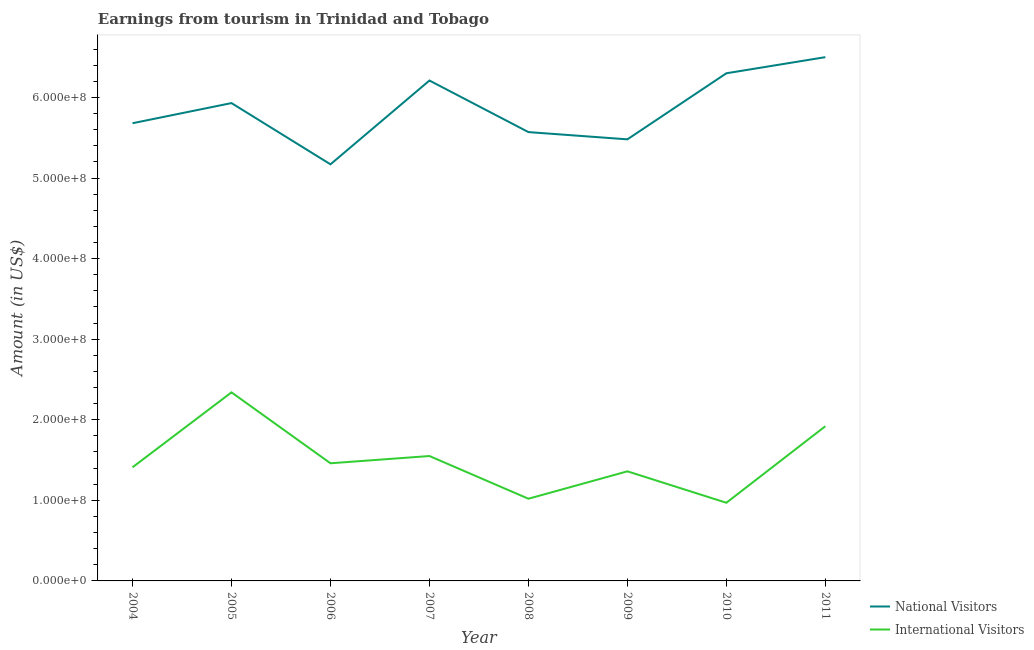What is the amount earned from national visitors in 2006?
Keep it short and to the point. 5.17e+08. Across all years, what is the maximum amount earned from national visitors?
Your answer should be very brief. 6.50e+08. Across all years, what is the minimum amount earned from national visitors?
Ensure brevity in your answer.  5.17e+08. In which year was the amount earned from national visitors minimum?
Give a very brief answer. 2006. What is the total amount earned from international visitors in the graph?
Provide a succinct answer. 1.20e+09. What is the difference between the amount earned from national visitors in 2005 and that in 2008?
Your answer should be compact. 3.60e+07. What is the difference between the amount earned from national visitors in 2007 and the amount earned from international visitors in 2009?
Provide a short and direct response. 4.85e+08. What is the average amount earned from national visitors per year?
Your answer should be very brief. 5.86e+08. In the year 2005, what is the difference between the amount earned from national visitors and amount earned from international visitors?
Ensure brevity in your answer.  3.59e+08. In how many years, is the amount earned from national visitors greater than 80000000 US$?
Your answer should be very brief. 8. What is the ratio of the amount earned from international visitors in 2004 to that in 2006?
Ensure brevity in your answer.  0.97. Is the amount earned from international visitors in 2005 less than that in 2008?
Give a very brief answer. No. What is the difference between the highest and the lowest amount earned from international visitors?
Your answer should be compact. 1.37e+08. In how many years, is the amount earned from national visitors greater than the average amount earned from national visitors taken over all years?
Your response must be concise. 4. Does the amount earned from international visitors monotonically increase over the years?
Ensure brevity in your answer.  No. Is the amount earned from international visitors strictly greater than the amount earned from national visitors over the years?
Provide a short and direct response. No. Is the amount earned from international visitors strictly less than the amount earned from national visitors over the years?
Give a very brief answer. Yes. How many years are there in the graph?
Ensure brevity in your answer.  8. Does the graph contain any zero values?
Give a very brief answer. No. Does the graph contain grids?
Provide a succinct answer. No. Where does the legend appear in the graph?
Ensure brevity in your answer.  Bottom right. How many legend labels are there?
Your response must be concise. 2. What is the title of the graph?
Provide a short and direct response. Earnings from tourism in Trinidad and Tobago. Does "Study and work" appear as one of the legend labels in the graph?
Your answer should be very brief. No. What is the Amount (in US$) in National Visitors in 2004?
Provide a short and direct response. 5.68e+08. What is the Amount (in US$) of International Visitors in 2004?
Make the answer very short. 1.41e+08. What is the Amount (in US$) of National Visitors in 2005?
Give a very brief answer. 5.93e+08. What is the Amount (in US$) of International Visitors in 2005?
Provide a short and direct response. 2.34e+08. What is the Amount (in US$) in National Visitors in 2006?
Offer a very short reply. 5.17e+08. What is the Amount (in US$) in International Visitors in 2006?
Keep it short and to the point. 1.46e+08. What is the Amount (in US$) in National Visitors in 2007?
Ensure brevity in your answer.  6.21e+08. What is the Amount (in US$) in International Visitors in 2007?
Your answer should be very brief. 1.55e+08. What is the Amount (in US$) of National Visitors in 2008?
Ensure brevity in your answer.  5.57e+08. What is the Amount (in US$) in International Visitors in 2008?
Give a very brief answer. 1.02e+08. What is the Amount (in US$) in National Visitors in 2009?
Your answer should be very brief. 5.48e+08. What is the Amount (in US$) of International Visitors in 2009?
Provide a short and direct response. 1.36e+08. What is the Amount (in US$) in National Visitors in 2010?
Offer a very short reply. 6.30e+08. What is the Amount (in US$) of International Visitors in 2010?
Offer a terse response. 9.70e+07. What is the Amount (in US$) of National Visitors in 2011?
Provide a short and direct response. 6.50e+08. What is the Amount (in US$) in International Visitors in 2011?
Offer a terse response. 1.92e+08. Across all years, what is the maximum Amount (in US$) in National Visitors?
Offer a terse response. 6.50e+08. Across all years, what is the maximum Amount (in US$) of International Visitors?
Provide a succinct answer. 2.34e+08. Across all years, what is the minimum Amount (in US$) of National Visitors?
Keep it short and to the point. 5.17e+08. Across all years, what is the minimum Amount (in US$) of International Visitors?
Give a very brief answer. 9.70e+07. What is the total Amount (in US$) in National Visitors in the graph?
Make the answer very short. 4.68e+09. What is the total Amount (in US$) in International Visitors in the graph?
Provide a succinct answer. 1.20e+09. What is the difference between the Amount (in US$) of National Visitors in 2004 and that in 2005?
Give a very brief answer. -2.50e+07. What is the difference between the Amount (in US$) of International Visitors in 2004 and that in 2005?
Your response must be concise. -9.30e+07. What is the difference between the Amount (in US$) in National Visitors in 2004 and that in 2006?
Offer a terse response. 5.10e+07. What is the difference between the Amount (in US$) in International Visitors in 2004 and that in 2006?
Offer a very short reply. -5.00e+06. What is the difference between the Amount (in US$) in National Visitors in 2004 and that in 2007?
Keep it short and to the point. -5.30e+07. What is the difference between the Amount (in US$) in International Visitors in 2004 and that in 2007?
Offer a terse response. -1.40e+07. What is the difference between the Amount (in US$) in National Visitors in 2004 and that in 2008?
Offer a terse response. 1.10e+07. What is the difference between the Amount (in US$) of International Visitors in 2004 and that in 2008?
Offer a terse response. 3.90e+07. What is the difference between the Amount (in US$) of International Visitors in 2004 and that in 2009?
Offer a terse response. 5.00e+06. What is the difference between the Amount (in US$) in National Visitors in 2004 and that in 2010?
Keep it short and to the point. -6.20e+07. What is the difference between the Amount (in US$) of International Visitors in 2004 and that in 2010?
Your answer should be very brief. 4.40e+07. What is the difference between the Amount (in US$) of National Visitors in 2004 and that in 2011?
Offer a terse response. -8.20e+07. What is the difference between the Amount (in US$) of International Visitors in 2004 and that in 2011?
Your answer should be very brief. -5.10e+07. What is the difference between the Amount (in US$) in National Visitors in 2005 and that in 2006?
Provide a succinct answer. 7.60e+07. What is the difference between the Amount (in US$) in International Visitors in 2005 and that in 2006?
Make the answer very short. 8.80e+07. What is the difference between the Amount (in US$) in National Visitors in 2005 and that in 2007?
Make the answer very short. -2.80e+07. What is the difference between the Amount (in US$) in International Visitors in 2005 and that in 2007?
Give a very brief answer. 7.90e+07. What is the difference between the Amount (in US$) in National Visitors in 2005 and that in 2008?
Keep it short and to the point. 3.60e+07. What is the difference between the Amount (in US$) in International Visitors in 2005 and that in 2008?
Your answer should be compact. 1.32e+08. What is the difference between the Amount (in US$) of National Visitors in 2005 and that in 2009?
Offer a terse response. 4.50e+07. What is the difference between the Amount (in US$) of International Visitors in 2005 and that in 2009?
Make the answer very short. 9.80e+07. What is the difference between the Amount (in US$) of National Visitors in 2005 and that in 2010?
Give a very brief answer. -3.70e+07. What is the difference between the Amount (in US$) of International Visitors in 2005 and that in 2010?
Offer a terse response. 1.37e+08. What is the difference between the Amount (in US$) in National Visitors in 2005 and that in 2011?
Your answer should be compact. -5.70e+07. What is the difference between the Amount (in US$) of International Visitors in 2005 and that in 2011?
Keep it short and to the point. 4.20e+07. What is the difference between the Amount (in US$) in National Visitors in 2006 and that in 2007?
Your answer should be very brief. -1.04e+08. What is the difference between the Amount (in US$) of International Visitors in 2006 and that in 2007?
Provide a succinct answer. -9.00e+06. What is the difference between the Amount (in US$) of National Visitors in 2006 and that in 2008?
Provide a succinct answer. -4.00e+07. What is the difference between the Amount (in US$) of International Visitors in 2006 and that in 2008?
Give a very brief answer. 4.40e+07. What is the difference between the Amount (in US$) of National Visitors in 2006 and that in 2009?
Offer a very short reply. -3.10e+07. What is the difference between the Amount (in US$) of International Visitors in 2006 and that in 2009?
Provide a succinct answer. 1.00e+07. What is the difference between the Amount (in US$) in National Visitors in 2006 and that in 2010?
Ensure brevity in your answer.  -1.13e+08. What is the difference between the Amount (in US$) of International Visitors in 2006 and that in 2010?
Provide a succinct answer. 4.90e+07. What is the difference between the Amount (in US$) of National Visitors in 2006 and that in 2011?
Provide a succinct answer. -1.33e+08. What is the difference between the Amount (in US$) of International Visitors in 2006 and that in 2011?
Your answer should be very brief. -4.60e+07. What is the difference between the Amount (in US$) in National Visitors in 2007 and that in 2008?
Offer a terse response. 6.40e+07. What is the difference between the Amount (in US$) of International Visitors in 2007 and that in 2008?
Make the answer very short. 5.30e+07. What is the difference between the Amount (in US$) of National Visitors in 2007 and that in 2009?
Offer a very short reply. 7.30e+07. What is the difference between the Amount (in US$) in International Visitors in 2007 and that in 2009?
Your response must be concise. 1.90e+07. What is the difference between the Amount (in US$) in National Visitors in 2007 and that in 2010?
Make the answer very short. -9.00e+06. What is the difference between the Amount (in US$) in International Visitors in 2007 and that in 2010?
Give a very brief answer. 5.80e+07. What is the difference between the Amount (in US$) in National Visitors in 2007 and that in 2011?
Ensure brevity in your answer.  -2.90e+07. What is the difference between the Amount (in US$) in International Visitors in 2007 and that in 2011?
Your answer should be compact. -3.70e+07. What is the difference between the Amount (in US$) in National Visitors in 2008 and that in 2009?
Give a very brief answer. 9.00e+06. What is the difference between the Amount (in US$) in International Visitors in 2008 and that in 2009?
Your answer should be compact. -3.40e+07. What is the difference between the Amount (in US$) of National Visitors in 2008 and that in 2010?
Provide a succinct answer. -7.30e+07. What is the difference between the Amount (in US$) in International Visitors in 2008 and that in 2010?
Give a very brief answer. 5.00e+06. What is the difference between the Amount (in US$) of National Visitors in 2008 and that in 2011?
Provide a succinct answer. -9.30e+07. What is the difference between the Amount (in US$) in International Visitors in 2008 and that in 2011?
Ensure brevity in your answer.  -9.00e+07. What is the difference between the Amount (in US$) in National Visitors in 2009 and that in 2010?
Provide a short and direct response. -8.20e+07. What is the difference between the Amount (in US$) of International Visitors in 2009 and that in 2010?
Your answer should be very brief. 3.90e+07. What is the difference between the Amount (in US$) in National Visitors in 2009 and that in 2011?
Give a very brief answer. -1.02e+08. What is the difference between the Amount (in US$) in International Visitors in 2009 and that in 2011?
Your answer should be very brief. -5.60e+07. What is the difference between the Amount (in US$) in National Visitors in 2010 and that in 2011?
Your answer should be compact. -2.00e+07. What is the difference between the Amount (in US$) in International Visitors in 2010 and that in 2011?
Your answer should be compact. -9.50e+07. What is the difference between the Amount (in US$) of National Visitors in 2004 and the Amount (in US$) of International Visitors in 2005?
Keep it short and to the point. 3.34e+08. What is the difference between the Amount (in US$) in National Visitors in 2004 and the Amount (in US$) in International Visitors in 2006?
Provide a short and direct response. 4.22e+08. What is the difference between the Amount (in US$) of National Visitors in 2004 and the Amount (in US$) of International Visitors in 2007?
Provide a short and direct response. 4.13e+08. What is the difference between the Amount (in US$) of National Visitors in 2004 and the Amount (in US$) of International Visitors in 2008?
Provide a short and direct response. 4.66e+08. What is the difference between the Amount (in US$) of National Visitors in 2004 and the Amount (in US$) of International Visitors in 2009?
Provide a short and direct response. 4.32e+08. What is the difference between the Amount (in US$) of National Visitors in 2004 and the Amount (in US$) of International Visitors in 2010?
Offer a very short reply. 4.71e+08. What is the difference between the Amount (in US$) in National Visitors in 2004 and the Amount (in US$) in International Visitors in 2011?
Keep it short and to the point. 3.76e+08. What is the difference between the Amount (in US$) of National Visitors in 2005 and the Amount (in US$) of International Visitors in 2006?
Make the answer very short. 4.47e+08. What is the difference between the Amount (in US$) of National Visitors in 2005 and the Amount (in US$) of International Visitors in 2007?
Your answer should be very brief. 4.38e+08. What is the difference between the Amount (in US$) in National Visitors in 2005 and the Amount (in US$) in International Visitors in 2008?
Offer a very short reply. 4.91e+08. What is the difference between the Amount (in US$) in National Visitors in 2005 and the Amount (in US$) in International Visitors in 2009?
Provide a succinct answer. 4.57e+08. What is the difference between the Amount (in US$) of National Visitors in 2005 and the Amount (in US$) of International Visitors in 2010?
Your answer should be very brief. 4.96e+08. What is the difference between the Amount (in US$) in National Visitors in 2005 and the Amount (in US$) in International Visitors in 2011?
Provide a short and direct response. 4.01e+08. What is the difference between the Amount (in US$) of National Visitors in 2006 and the Amount (in US$) of International Visitors in 2007?
Keep it short and to the point. 3.62e+08. What is the difference between the Amount (in US$) of National Visitors in 2006 and the Amount (in US$) of International Visitors in 2008?
Your answer should be very brief. 4.15e+08. What is the difference between the Amount (in US$) of National Visitors in 2006 and the Amount (in US$) of International Visitors in 2009?
Offer a terse response. 3.81e+08. What is the difference between the Amount (in US$) in National Visitors in 2006 and the Amount (in US$) in International Visitors in 2010?
Your answer should be compact. 4.20e+08. What is the difference between the Amount (in US$) of National Visitors in 2006 and the Amount (in US$) of International Visitors in 2011?
Provide a short and direct response. 3.25e+08. What is the difference between the Amount (in US$) in National Visitors in 2007 and the Amount (in US$) in International Visitors in 2008?
Provide a short and direct response. 5.19e+08. What is the difference between the Amount (in US$) of National Visitors in 2007 and the Amount (in US$) of International Visitors in 2009?
Offer a terse response. 4.85e+08. What is the difference between the Amount (in US$) of National Visitors in 2007 and the Amount (in US$) of International Visitors in 2010?
Provide a succinct answer. 5.24e+08. What is the difference between the Amount (in US$) of National Visitors in 2007 and the Amount (in US$) of International Visitors in 2011?
Offer a terse response. 4.29e+08. What is the difference between the Amount (in US$) of National Visitors in 2008 and the Amount (in US$) of International Visitors in 2009?
Offer a very short reply. 4.21e+08. What is the difference between the Amount (in US$) in National Visitors in 2008 and the Amount (in US$) in International Visitors in 2010?
Provide a short and direct response. 4.60e+08. What is the difference between the Amount (in US$) of National Visitors in 2008 and the Amount (in US$) of International Visitors in 2011?
Offer a terse response. 3.65e+08. What is the difference between the Amount (in US$) in National Visitors in 2009 and the Amount (in US$) in International Visitors in 2010?
Your response must be concise. 4.51e+08. What is the difference between the Amount (in US$) of National Visitors in 2009 and the Amount (in US$) of International Visitors in 2011?
Your response must be concise. 3.56e+08. What is the difference between the Amount (in US$) of National Visitors in 2010 and the Amount (in US$) of International Visitors in 2011?
Make the answer very short. 4.38e+08. What is the average Amount (in US$) in National Visitors per year?
Ensure brevity in your answer.  5.86e+08. What is the average Amount (in US$) of International Visitors per year?
Your response must be concise. 1.50e+08. In the year 2004, what is the difference between the Amount (in US$) in National Visitors and Amount (in US$) in International Visitors?
Offer a very short reply. 4.27e+08. In the year 2005, what is the difference between the Amount (in US$) of National Visitors and Amount (in US$) of International Visitors?
Offer a very short reply. 3.59e+08. In the year 2006, what is the difference between the Amount (in US$) of National Visitors and Amount (in US$) of International Visitors?
Provide a succinct answer. 3.71e+08. In the year 2007, what is the difference between the Amount (in US$) of National Visitors and Amount (in US$) of International Visitors?
Keep it short and to the point. 4.66e+08. In the year 2008, what is the difference between the Amount (in US$) of National Visitors and Amount (in US$) of International Visitors?
Your response must be concise. 4.55e+08. In the year 2009, what is the difference between the Amount (in US$) of National Visitors and Amount (in US$) of International Visitors?
Your answer should be very brief. 4.12e+08. In the year 2010, what is the difference between the Amount (in US$) in National Visitors and Amount (in US$) in International Visitors?
Provide a short and direct response. 5.33e+08. In the year 2011, what is the difference between the Amount (in US$) in National Visitors and Amount (in US$) in International Visitors?
Your answer should be compact. 4.58e+08. What is the ratio of the Amount (in US$) in National Visitors in 2004 to that in 2005?
Offer a very short reply. 0.96. What is the ratio of the Amount (in US$) in International Visitors in 2004 to that in 2005?
Offer a very short reply. 0.6. What is the ratio of the Amount (in US$) of National Visitors in 2004 to that in 2006?
Your answer should be very brief. 1.1. What is the ratio of the Amount (in US$) in International Visitors in 2004 to that in 2006?
Ensure brevity in your answer.  0.97. What is the ratio of the Amount (in US$) of National Visitors in 2004 to that in 2007?
Offer a terse response. 0.91. What is the ratio of the Amount (in US$) in International Visitors in 2004 to that in 2007?
Provide a short and direct response. 0.91. What is the ratio of the Amount (in US$) in National Visitors in 2004 to that in 2008?
Provide a short and direct response. 1.02. What is the ratio of the Amount (in US$) in International Visitors in 2004 to that in 2008?
Your answer should be very brief. 1.38. What is the ratio of the Amount (in US$) of National Visitors in 2004 to that in 2009?
Ensure brevity in your answer.  1.04. What is the ratio of the Amount (in US$) in International Visitors in 2004 to that in 2009?
Keep it short and to the point. 1.04. What is the ratio of the Amount (in US$) of National Visitors in 2004 to that in 2010?
Make the answer very short. 0.9. What is the ratio of the Amount (in US$) in International Visitors in 2004 to that in 2010?
Your answer should be compact. 1.45. What is the ratio of the Amount (in US$) in National Visitors in 2004 to that in 2011?
Make the answer very short. 0.87. What is the ratio of the Amount (in US$) in International Visitors in 2004 to that in 2011?
Offer a very short reply. 0.73. What is the ratio of the Amount (in US$) of National Visitors in 2005 to that in 2006?
Ensure brevity in your answer.  1.15. What is the ratio of the Amount (in US$) in International Visitors in 2005 to that in 2006?
Your answer should be very brief. 1.6. What is the ratio of the Amount (in US$) in National Visitors in 2005 to that in 2007?
Offer a terse response. 0.95. What is the ratio of the Amount (in US$) of International Visitors in 2005 to that in 2007?
Give a very brief answer. 1.51. What is the ratio of the Amount (in US$) in National Visitors in 2005 to that in 2008?
Offer a very short reply. 1.06. What is the ratio of the Amount (in US$) of International Visitors in 2005 to that in 2008?
Offer a very short reply. 2.29. What is the ratio of the Amount (in US$) of National Visitors in 2005 to that in 2009?
Keep it short and to the point. 1.08. What is the ratio of the Amount (in US$) in International Visitors in 2005 to that in 2009?
Keep it short and to the point. 1.72. What is the ratio of the Amount (in US$) of National Visitors in 2005 to that in 2010?
Offer a terse response. 0.94. What is the ratio of the Amount (in US$) in International Visitors in 2005 to that in 2010?
Your response must be concise. 2.41. What is the ratio of the Amount (in US$) of National Visitors in 2005 to that in 2011?
Offer a very short reply. 0.91. What is the ratio of the Amount (in US$) of International Visitors in 2005 to that in 2011?
Your answer should be very brief. 1.22. What is the ratio of the Amount (in US$) of National Visitors in 2006 to that in 2007?
Give a very brief answer. 0.83. What is the ratio of the Amount (in US$) in International Visitors in 2006 to that in 2007?
Provide a short and direct response. 0.94. What is the ratio of the Amount (in US$) in National Visitors in 2006 to that in 2008?
Make the answer very short. 0.93. What is the ratio of the Amount (in US$) of International Visitors in 2006 to that in 2008?
Give a very brief answer. 1.43. What is the ratio of the Amount (in US$) in National Visitors in 2006 to that in 2009?
Offer a very short reply. 0.94. What is the ratio of the Amount (in US$) of International Visitors in 2006 to that in 2009?
Provide a short and direct response. 1.07. What is the ratio of the Amount (in US$) in National Visitors in 2006 to that in 2010?
Provide a succinct answer. 0.82. What is the ratio of the Amount (in US$) in International Visitors in 2006 to that in 2010?
Your answer should be compact. 1.51. What is the ratio of the Amount (in US$) of National Visitors in 2006 to that in 2011?
Keep it short and to the point. 0.8. What is the ratio of the Amount (in US$) of International Visitors in 2006 to that in 2011?
Offer a terse response. 0.76. What is the ratio of the Amount (in US$) in National Visitors in 2007 to that in 2008?
Give a very brief answer. 1.11. What is the ratio of the Amount (in US$) in International Visitors in 2007 to that in 2008?
Give a very brief answer. 1.52. What is the ratio of the Amount (in US$) of National Visitors in 2007 to that in 2009?
Keep it short and to the point. 1.13. What is the ratio of the Amount (in US$) in International Visitors in 2007 to that in 2009?
Provide a succinct answer. 1.14. What is the ratio of the Amount (in US$) in National Visitors in 2007 to that in 2010?
Provide a succinct answer. 0.99. What is the ratio of the Amount (in US$) of International Visitors in 2007 to that in 2010?
Make the answer very short. 1.6. What is the ratio of the Amount (in US$) of National Visitors in 2007 to that in 2011?
Your response must be concise. 0.96. What is the ratio of the Amount (in US$) of International Visitors in 2007 to that in 2011?
Your answer should be compact. 0.81. What is the ratio of the Amount (in US$) of National Visitors in 2008 to that in 2009?
Offer a very short reply. 1.02. What is the ratio of the Amount (in US$) of National Visitors in 2008 to that in 2010?
Offer a terse response. 0.88. What is the ratio of the Amount (in US$) of International Visitors in 2008 to that in 2010?
Ensure brevity in your answer.  1.05. What is the ratio of the Amount (in US$) of National Visitors in 2008 to that in 2011?
Offer a very short reply. 0.86. What is the ratio of the Amount (in US$) in International Visitors in 2008 to that in 2011?
Give a very brief answer. 0.53. What is the ratio of the Amount (in US$) in National Visitors in 2009 to that in 2010?
Make the answer very short. 0.87. What is the ratio of the Amount (in US$) in International Visitors in 2009 to that in 2010?
Keep it short and to the point. 1.4. What is the ratio of the Amount (in US$) of National Visitors in 2009 to that in 2011?
Your answer should be very brief. 0.84. What is the ratio of the Amount (in US$) of International Visitors in 2009 to that in 2011?
Provide a succinct answer. 0.71. What is the ratio of the Amount (in US$) of National Visitors in 2010 to that in 2011?
Give a very brief answer. 0.97. What is the ratio of the Amount (in US$) in International Visitors in 2010 to that in 2011?
Your response must be concise. 0.51. What is the difference between the highest and the second highest Amount (in US$) of International Visitors?
Make the answer very short. 4.20e+07. What is the difference between the highest and the lowest Amount (in US$) in National Visitors?
Give a very brief answer. 1.33e+08. What is the difference between the highest and the lowest Amount (in US$) in International Visitors?
Ensure brevity in your answer.  1.37e+08. 